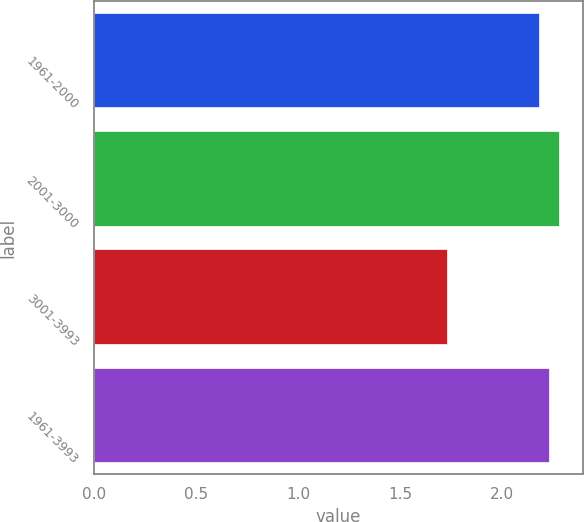<chart> <loc_0><loc_0><loc_500><loc_500><bar_chart><fcel>1961-2000<fcel>2001-3000<fcel>3001-3993<fcel>1961-3993<nl><fcel>2.18<fcel>2.28<fcel>1.73<fcel>2.23<nl></chart> 